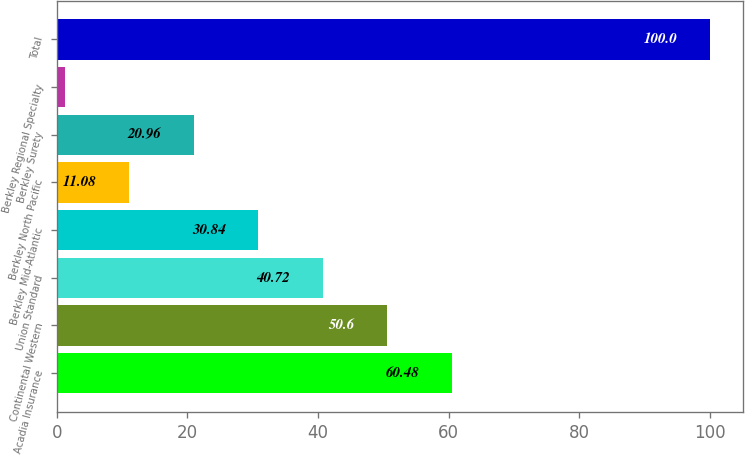<chart> <loc_0><loc_0><loc_500><loc_500><bar_chart><fcel>Acadia Insurance<fcel>Continental Western<fcel>Union Standard<fcel>Berkley Mid-Atlantic<fcel>Berkley North Pacific<fcel>Berkley Surety<fcel>Berkley Regional Specialty<fcel>Total<nl><fcel>60.48<fcel>50.6<fcel>40.72<fcel>30.84<fcel>11.08<fcel>20.96<fcel>1.2<fcel>100<nl></chart> 